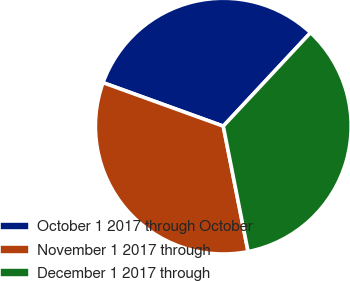Convert chart. <chart><loc_0><loc_0><loc_500><loc_500><pie_chart><fcel>October 1 2017 through October<fcel>November 1 2017 through<fcel>December 1 2017 through<nl><fcel>31.43%<fcel>33.63%<fcel>34.94%<nl></chart> 